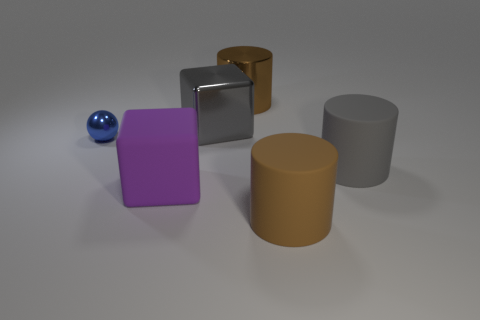Subtract all rubber cylinders. How many cylinders are left? 1 Add 2 purple rubber blocks. How many objects exist? 8 Subtract all blocks. How many objects are left? 4 Subtract 1 cubes. How many cubes are left? 1 Subtract all gray cylinders. How many cylinders are left? 2 Subtract all blue cylinders. Subtract all cyan blocks. How many cylinders are left? 3 Subtract all brown blocks. How many green cylinders are left? 0 Subtract all tiny gray metallic cubes. Subtract all gray shiny objects. How many objects are left? 5 Add 3 large brown rubber objects. How many large brown rubber objects are left? 4 Add 2 large gray blocks. How many large gray blocks exist? 3 